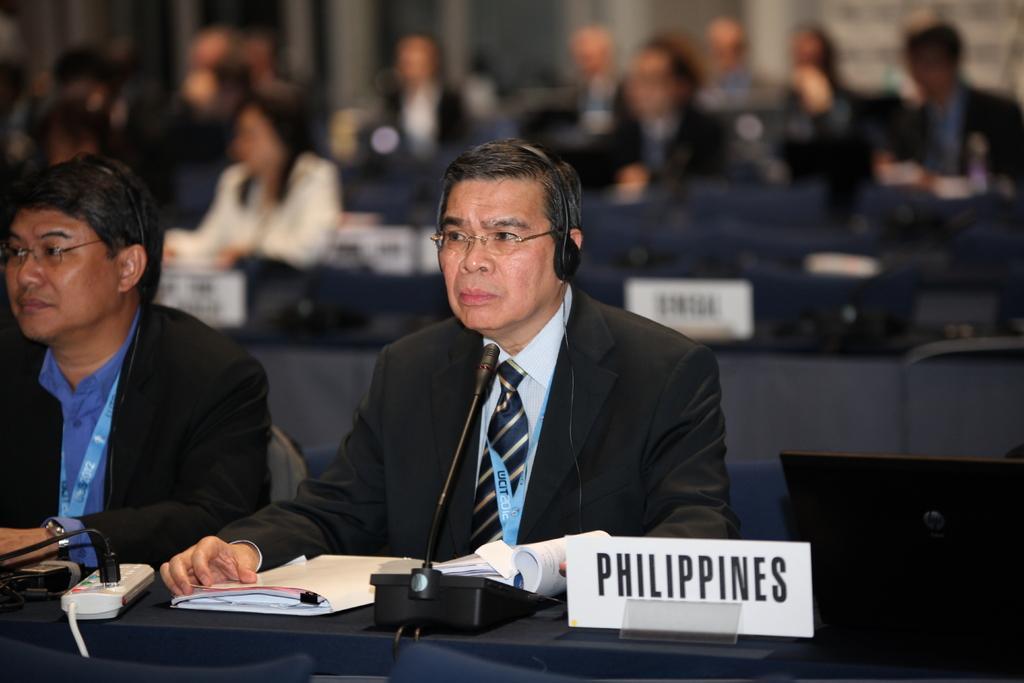Describe this image in one or two sentences. In this image, there are two persons wearing clothes and sitting in front of the table contains mic, file, switchboard and name plate. The person who is in the middle of the image wearing a headset on his head. In the background, image is blurred. 